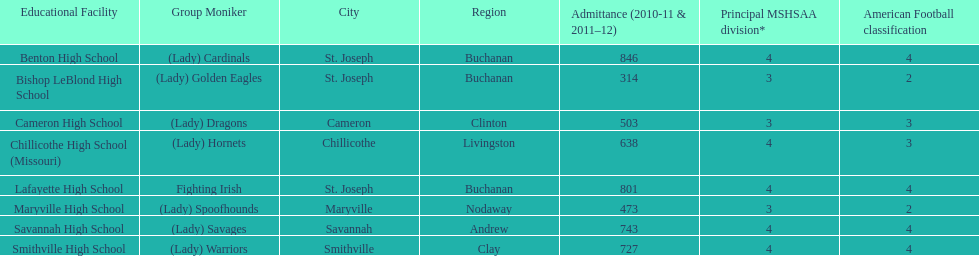Which school has the largest enrollment? Benton High School. 